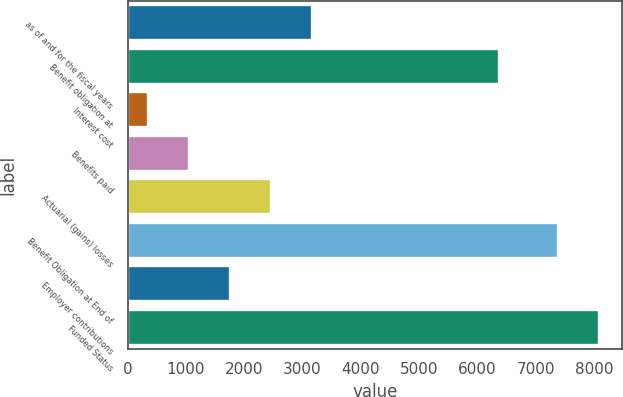Convert chart. <chart><loc_0><loc_0><loc_500><loc_500><bar_chart><fcel>as of and for the fiscal years<fcel>Benefit obligation at<fcel>Interest cost<fcel>Benefits paid<fcel>Actuarial (gains) losses<fcel>Benefit Obligation at End of<fcel>Employer contributions<fcel>Funded Status<nl><fcel>3163.8<fcel>6371<fcel>353<fcel>1055.7<fcel>2461.1<fcel>7380<fcel>1758.4<fcel>8082.7<nl></chart> 